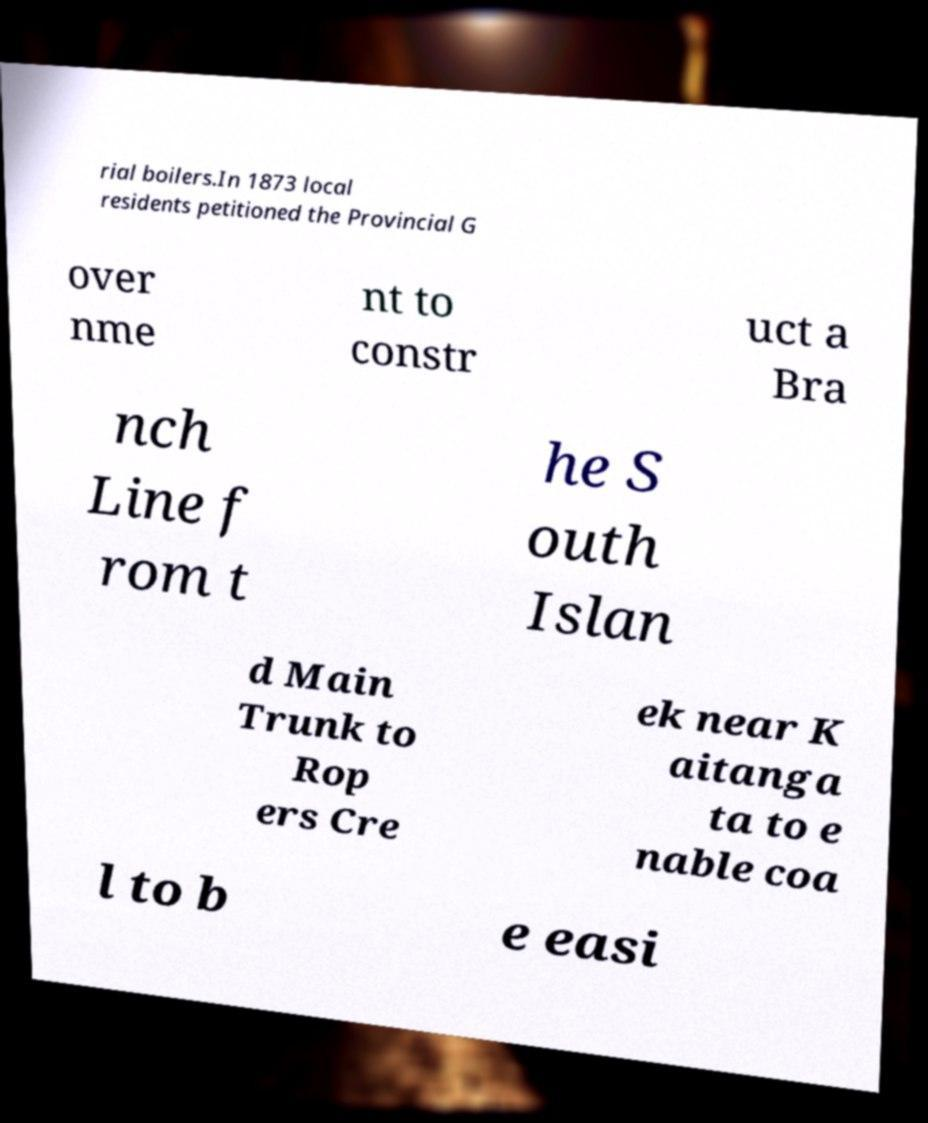Could you extract and type out the text from this image? rial boilers.In 1873 local residents petitioned the Provincial G over nme nt to constr uct a Bra nch Line f rom t he S outh Islan d Main Trunk to Rop ers Cre ek near K aitanga ta to e nable coa l to b e easi 